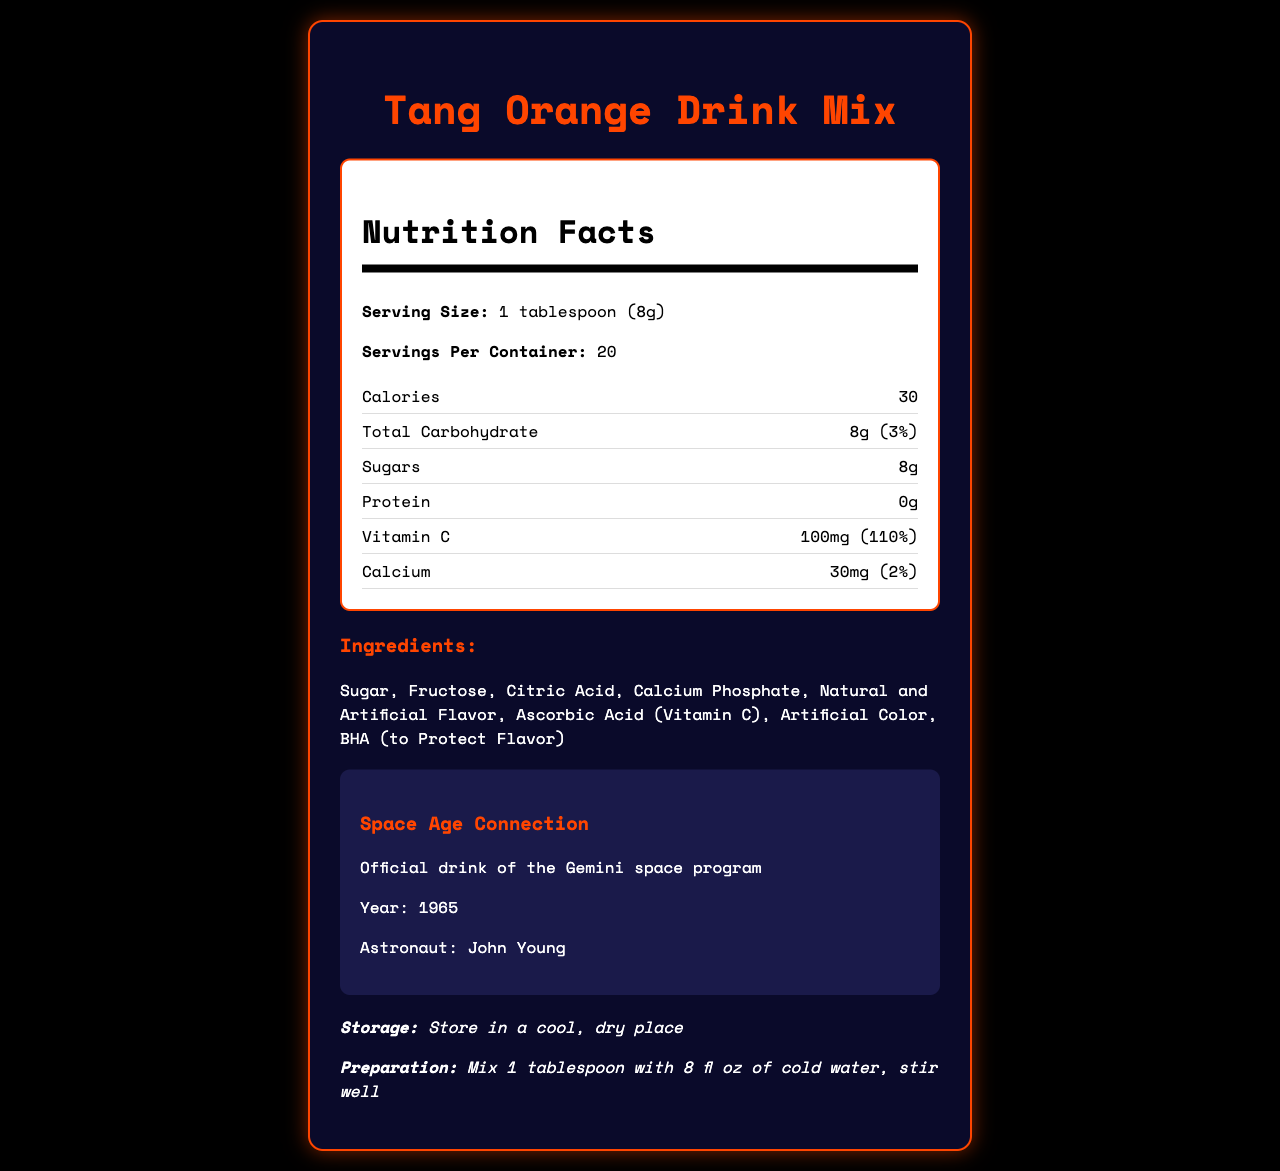what is the serving size for Tang Orange Drink Mix? The serving size is explicitly mentioned in the document as "1 tablespoon (8g)".
Answer: 1 tablespoon (8g) how many calories are there per serving? The document states that there are 30 calories per serving.
Answer: 30 does Tang provide any protein per serving? The nutrition facts state that the protein content is 0g per serving.
Answer: No what is the daily value percentage of vitamin C per serving? The document lists that the daily value percentage of vitamin C per serving is 110%.
Answer: 110% what is the serving size for Tang Orange Drink Mix The serving size is clearly listed as "1 tablespoon (8g)" in the nutrition facts section.
Answer: 1 tablespoon (8g) based on the document, list the main ingredients in Tang Orange Drink Mix. The ingredients are listed in the ingredients section.
Answer: Sugar, Fructose, Citric Acid, Calcium Phosphate, Natural and Artificial Flavor, Ascorbic Acid (Vitamin C), Artificial Color, BHA (to Protect Flavor) what is the significance of Tang's connection to the space program? The document indicates that Tang was the official drink of the Gemini space program.
Answer: Official drink of the Gemini space program who invented Tang and when? The historical context states that Tang was invented by William A. Mitchell in 1957.
Answer: William A. Mitchell, 1957 how much calcium does one serving of Tang Orange Drink Mix provide? The nutrition facts state that one serving provides 30mg of calcium.
Answer: 30mg how should Tang Orange Drink Mix be stored? A. In the refrigerator B. In a cool, dry place C. At room temperature The storage instructions in the document specify to store Tang in a cool, dry place.
Answer: B. In a cool, dry place which astronaut was associated with Tang and the space program? A. John Young B. Neil Armstrong C. Buzz Aldrin D. Alan Shepard The space program section of the document indicates that John Young was the astronaut associated with Tang.
Answer: A. John Young what year did Tang become the official drink of the Gemini space program? A. 1963 B. 1965 C. 1967 The document lists the year 1965 in the space program section.
Answer: B. 1965 does Tang provide more than 100% of the daily recommended vitamin C per serving? The document states that Tang provides 110% of the daily vitamin C requirement per serving.
Answer: Yes summarize the main idea of the document The document combines nutritional information with historical context, emphasizing both the health benefits of Tang and its unique connection to the space-age era.
Answer: The document provides comprehensive nutrition facts for Tang Orange Drink Mix, detailing its serving size, calorie content, carbohydrate content, and high vitamin C content. It also highlights Tang’s historical significance as the official drink of the Gemini space program in 1965 and provides storage and preparation instructions. how many grams of sugar are in each serving of Tang? The document states that there are 8 grams of sugar per serving.
Answer: 8g What is the total carbohydrate content in a serving of Tang? A. 5g B. 8g C. 10g D. 12g The nutrition facts specify that each serving contains 8 grams of total carbohydrates.
Answer: B. 8g what are the preparation instructions for Tang Orange Drink Mix? The preparation instructions state to mix 1 tablespoon of Tang with 8 fl oz of cold water and stir well.
Answer: Mix 1 tablespoon with 8 fl oz of cold water, stir well can you determine the expiration date of Tang Orange Drink Mix from the document? The document does not provide any details regarding the expiration date of the product.
Answer: Not enough information 